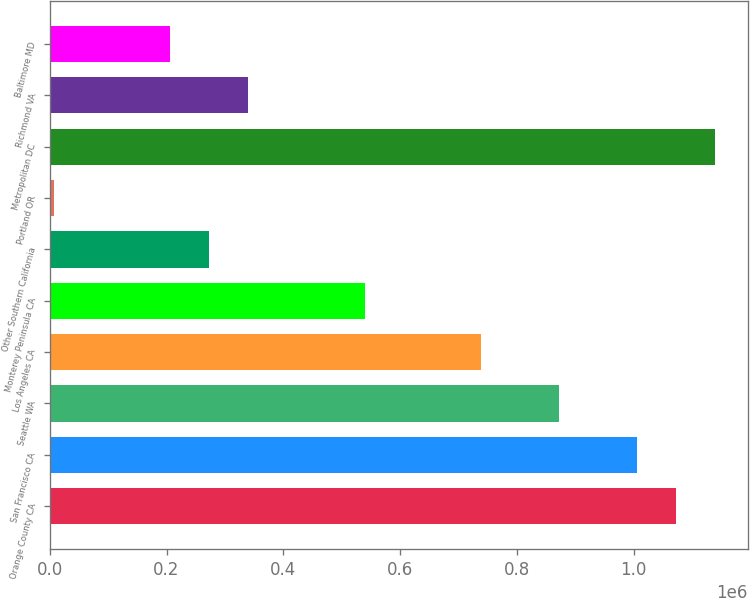<chart> <loc_0><loc_0><loc_500><loc_500><bar_chart><fcel>Orange County CA<fcel>San Francisco CA<fcel>Seattle WA<fcel>Los Angeles CA<fcel>Monterey Peninsula CA<fcel>Other Southern California<fcel>Portland OR<fcel>Metropolitan DC<fcel>Richmond VA<fcel>Baltimore MD<nl><fcel>1.07191e+06<fcel>1.00533e+06<fcel>872154<fcel>738981<fcel>539220<fcel>272873<fcel>6526<fcel>1.1385e+06<fcel>339460<fcel>206286<nl></chart> 